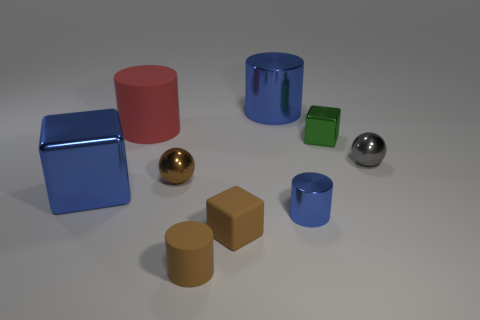What is the material of the cylinder that is the same color as the rubber cube?
Make the answer very short. Rubber. How many matte objects are small cylinders or green blocks?
Your answer should be very brief. 1. How many other things are the same shape as the small blue shiny thing?
Keep it short and to the point. 3. Are there more blue metallic blocks than small matte objects?
Provide a short and direct response. No. There is a metal ball left of the blue metal object behind the small sphere to the left of the gray metal object; what size is it?
Offer a very short reply. Small. What is the size of the blue shiny cylinder behind the red cylinder?
Give a very brief answer. Large. What number of objects are either tiny brown shiny spheres or big matte cylinders that are behind the tiny brown shiny object?
Offer a very short reply. 2. What number of other objects are the same size as the brown shiny object?
Offer a terse response. 5. There is another brown object that is the same shape as the large rubber thing; what material is it?
Provide a succinct answer. Rubber. Are there more small gray metal things that are to the left of the large blue shiny cylinder than things?
Provide a short and direct response. No. 